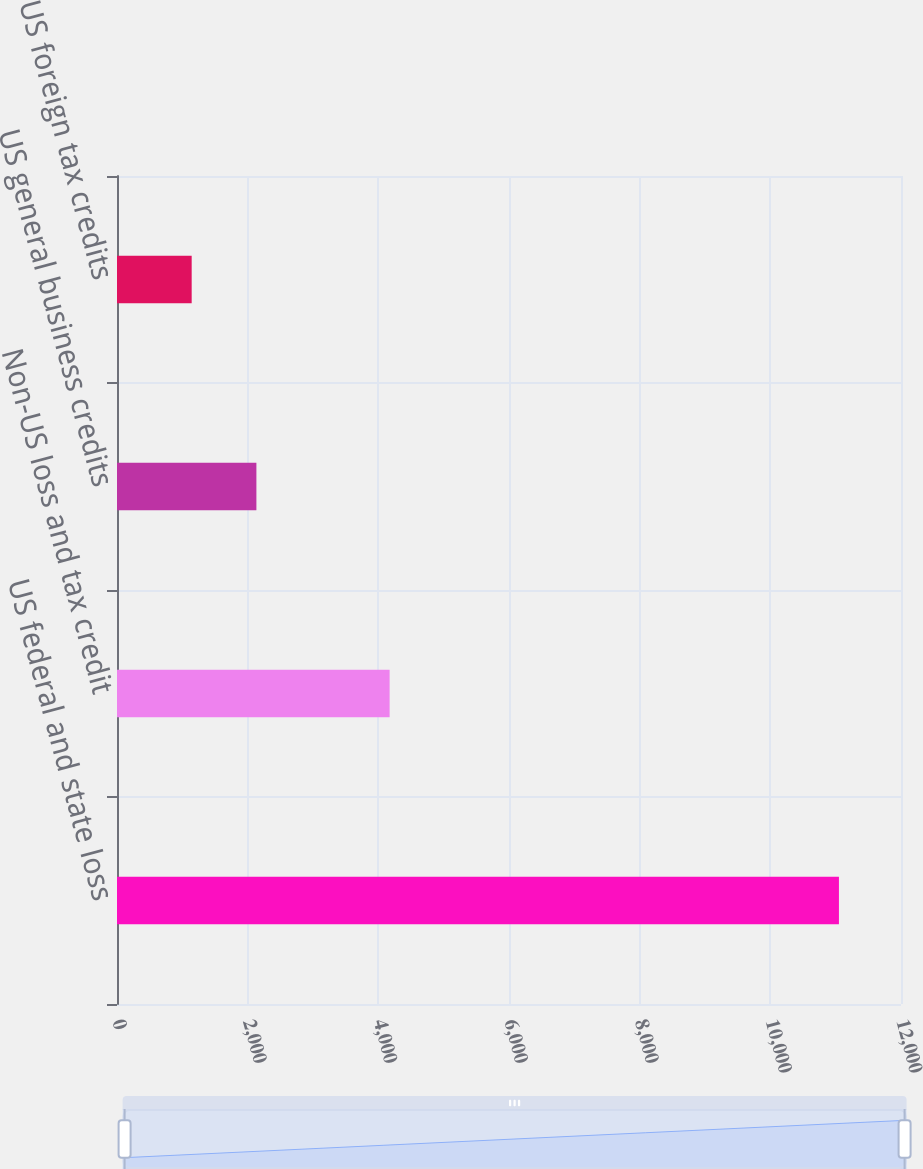Convert chart. <chart><loc_0><loc_0><loc_500><loc_500><bar_chart><fcel>US federal and state loss<fcel>Non-US loss and tax credit<fcel>US general business credits<fcel>US foreign tax credits<nl><fcel>11050<fcel>4173<fcel>2133.7<fcel>1143<nl></chart> 